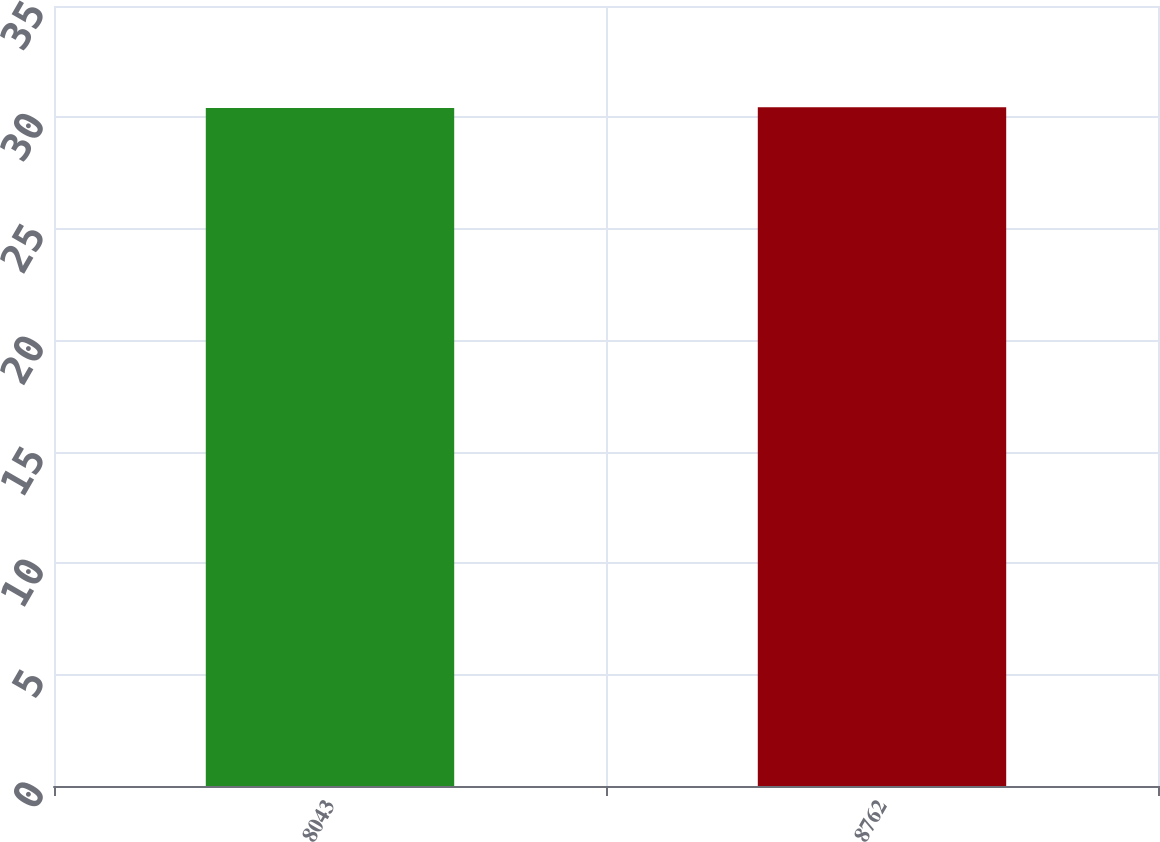Convert chart. <chart><loc_0><loc_0><loc_500><loc_500><bar_chart><fcel>8043<fcel>8762<nl><fcel>30.42<fcel>30.46<nl></chart> 